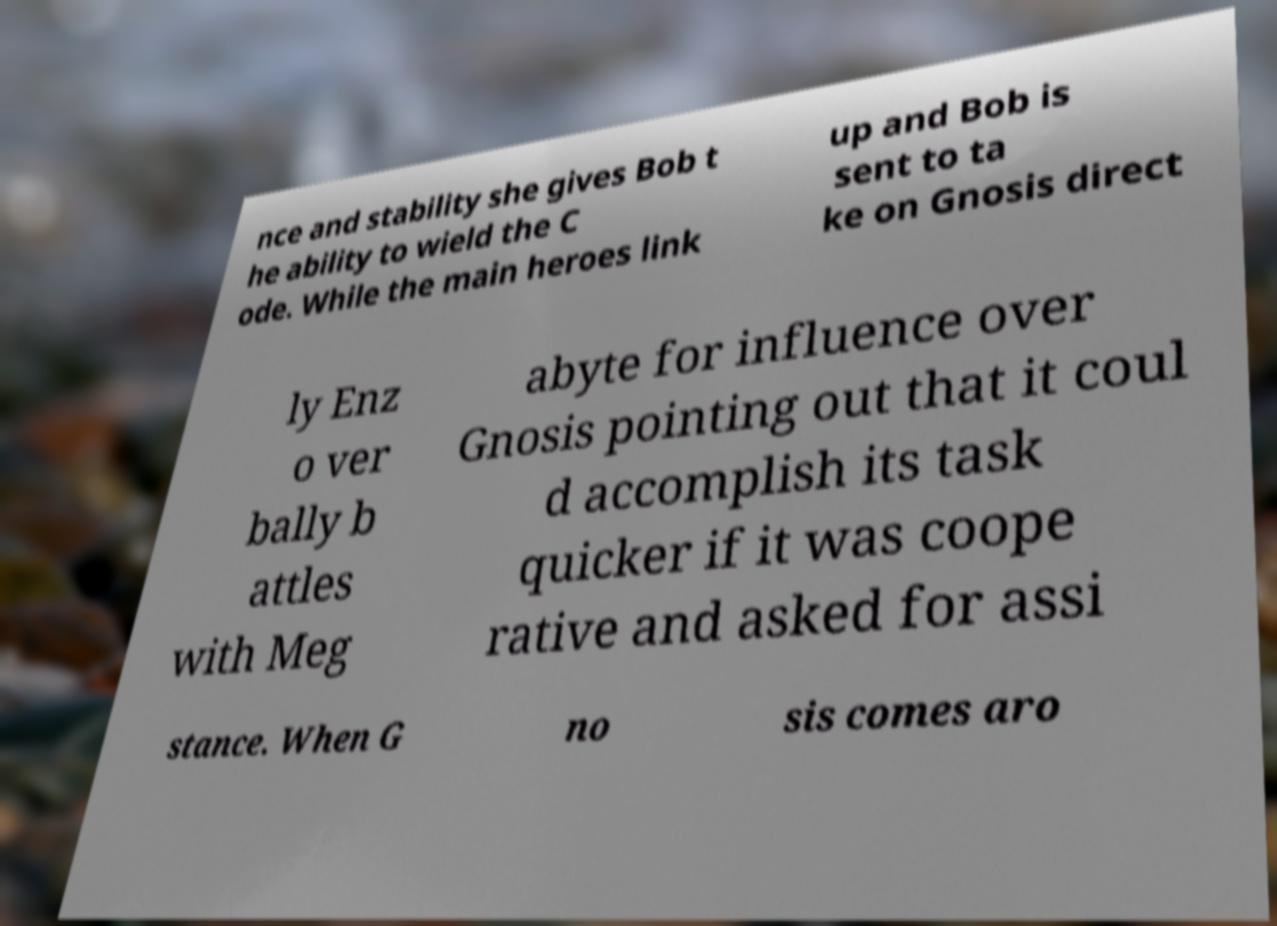I need the written content from this picture converted into text. Can you do that? nce and stability she gives Bob t he ability to wield the C ode. While the main heroes link up and Bob is sent to ta ke on Gnosis direct ly Enz o ver bally b attles with Meg abyte for influence over Gnosis pointing out that it coul d accomplish its task quicker if it was coope rative and asked for assi stance. When G no sis comes aro 